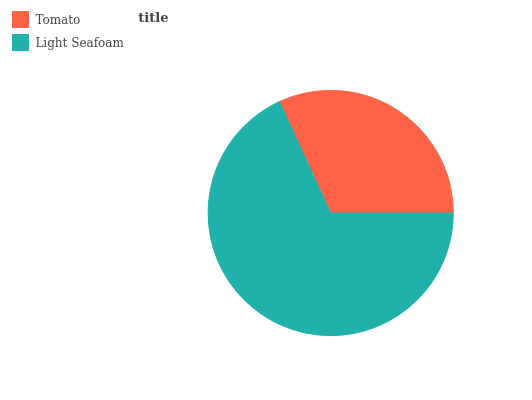Is Tomato the minimum?
Answer yes or no. Yes. Is Light Seafoam the maximum?
Answer yes or no. Yes. Is Light Seafoam the minimum?
Answer yes or no. No. Is Light Seafoam greater than Tomato?
Answer yes or no. Yes. Is Tomato less than Light Seafoam?
Answer yes or no. Yes. Is Tomato greater than Light Seafoam?
Answer yes or no. No. Is Light Seafoam less than Tomato?
Answer yes or no. No. Is Light Seafoam the high median?
Answer yes or no. Yes. Is Tomato the low median?
Answer yes or no. Yes. Is Tomato the high median?
Answer yes or no. No. Is Light Seafoam the low median?
Answer yes or no. No. 